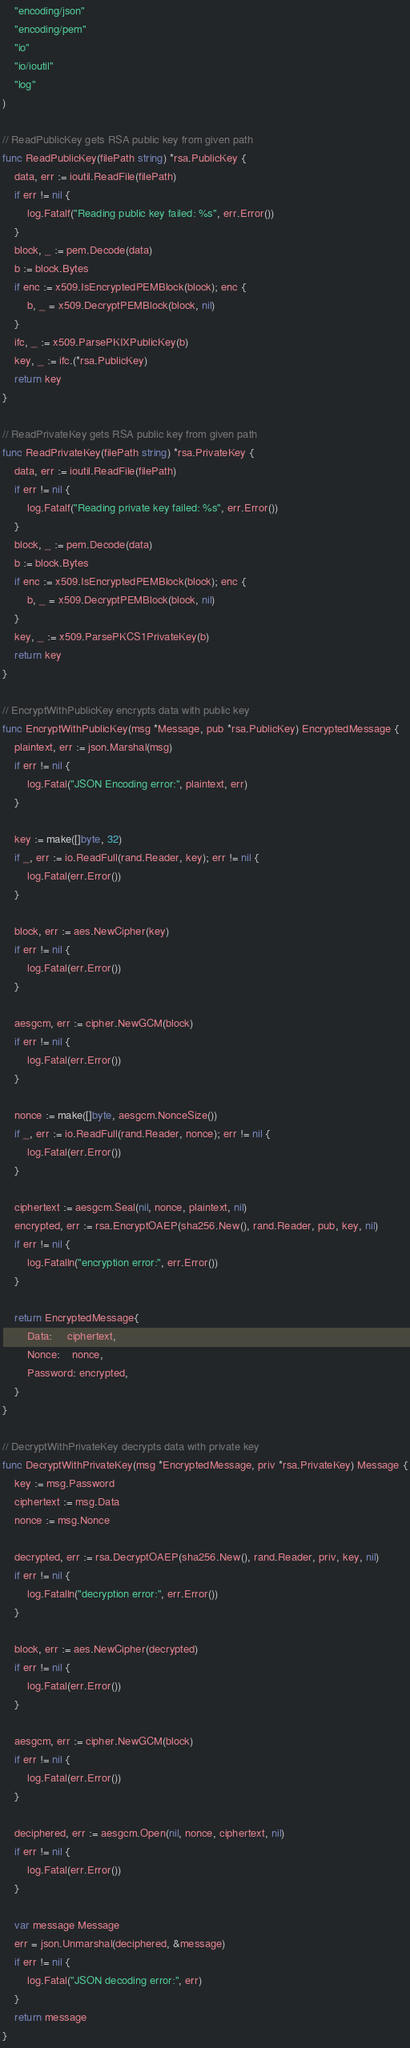Convert code to text. <code><loc_0><loc_0><loc_500><loc_500><_Go_>	"encoding/json"
	"encoding/pem"
	"io"
	"io/ioutil"
	"log"
)

// ReadPublicKey gets RSA public key from given path
func ReadPublicKey(filePath string) *rsa.PublicKey {
	data, err := ioutil.ReadFile(filePath)
	if err != nil {
		log.Fatalf("Reading public key failed: %s", err.Error())
	}
	block, _ := pem.Decode(data)
	b := block.Bytes
	if enc := x509.IsEncryptedPEMBlock(block); enc {
		b, _ = x509.DecryptPEMBlock(block, nil)
	}
	ifc, _ := x509.ParsePKIXPublicKey(b)
	key, _ := ifc.(*rsa.PublicKey)
	return key
}

// ReadPrivateKey gets RSA public key from given path
func ReadPrivateKey(filePath string) *rsa.PrivateKey {
	data, err := ioutil.ReadFile(filePath)
	if err != nil {
		log.Fatalf("Reading private key failed: %s", err.Error())
	}
	block, _ := pem.Decode(data)
	b := block.Bytes
	if enc := x509.IsEncryptedPEMBlock(block); enc {
		b, _ = x509.DecryptPEMBlock(block, nil)
	}
	key, _ := x509.ParsePKCS1PrivateKey(b)
	return key
}

// EncryptWithPublicKey encrypts data with public key
func EncryptWithPublicKey(msg *Message, pub *rsa.PublicKey) EncryptedMessage {
	plaintext, err := json.Marshal(msg)
	if err != nil {
		log.Fatal("JSON Encoding error:", plaintext, err)
	}

	key := make([]byte, 32)
	if _, err := io.ReadFull(rand.Reader, key); err != nil {
		log.Fatal(err.Error())
	}

	block, err := aes.NewCipher(key)
	if err != nil {
		log.Fatal(err.Error())
	}

	aesgcm, err := cipher.NewGCM(block)
	if err != nil {
		log.Fatal(err.Error())
	}

	nonce := make([]byte, aesgcm.NonceSize())
	if _, err := io.ReadFull(rand.Reader, nonce); err != nil {
		log.Fatal(err.Error())
	}

	ciphertext := aesgcm.Seal(nil, nonce, plaintext, nil)
	encrypted, err := rsa.EncryptOAEP(sha256.New(), rand.Reader, pub, key, nil)
	if err != nil {
		log.Fatalln("encryption error:", err.Error())
	}

	return EncryptedMessage{
		Data:     ciphertext,
		Nonce:    nonce,
		Password: encrypted,
	}
}

// DecryptWithPrivateKey decrypts data with private key
func DecryptWithPrivateKey(msg *EncryptedMessage, priv *rsa.PrivateKey) Message {
	key := msg.Password
	ciphertext := msg.Data
	nonce := msg.Nonce

	decrypted, err := rsa.DecryptOAEP(sha256.New(), rand.Reader, priv, key, nil)
	if err != nil {
		log.Fatalln("decryption error:", err.Error())
	}

	block, err := aes.NewCipher(decrypted)
	if err != nil {
		log.Fatal(err.Error())
	}

	aesgcm, err := cipher.NewGCM(block)
	if err != nil {
		log.Fatal(err.Error())
	}

	deciphered, err := aesgcm.Open(nil, nonce, ciphertext, nil)
	if err != nil {
		log.Fatal(err.Error())
	}

	var message Message
	err = json.Unmarshal(deciphered, &message)
	if err != nil {
		log.Fatal("JSON decoding error:", err)
	}
	return message
}
</code> 